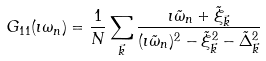<formula> <loc_0><loc_0><loc_500><loc_500>G _ { 1 1 } ( \imath \omega _ { n } ) = \frac { 1 } { N } \sum _ { \vec { k } } \frac { \imath \tilde { \omega } _ { n } + \tilde { \xi } _ { \vec { k } } } { ( { \imath \tilde { \omega } _ { n } } ) ^ { 2 } - { \tilde { \xi } _ { \vec { k } } } ^ { 2 } - { \tilde { \Delta } _ { \vec { k } } } ^ { 2 } }</formula> 